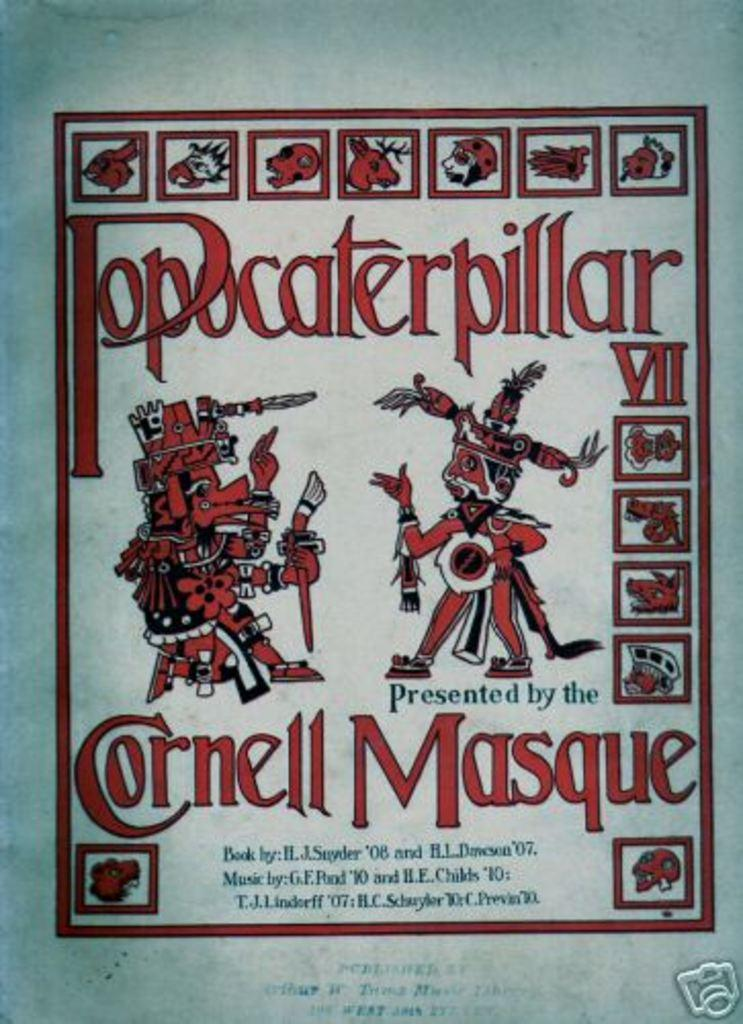<image>
Offer a succinct explanation of the picture presented. Poster with two characters and says presented by Cornell Masque. 